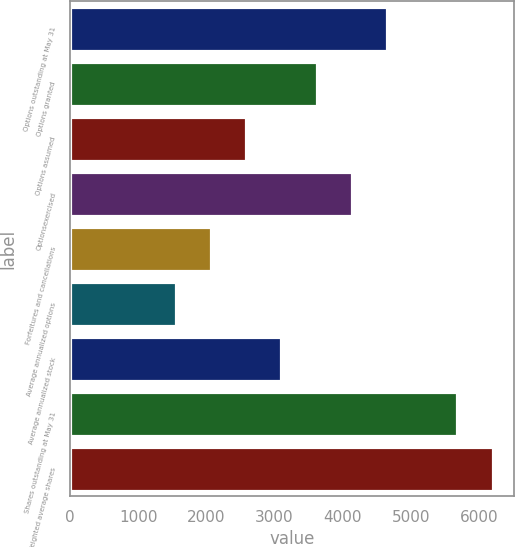Convert chart to OTSL. <chart><loc_0><loc_0><loc_500><loc_500><bar_chart><fcel>Options outstanding at May 31<fcel>Options granted<fcel>Options assumed<fcel>Optionsexercised<fcel>Forfeitures and cancellations<fcel>Average annualized options<fcel>Average annualized stock<fcel>Shares outstanding at May 31<fcel>Weighted average shares<nl><fcel>4649.55<fcel>3616.65<fcel>2583.75<fcel>4133.1<fcel>2067.3<fcel>1550.85<fcel>3100.2<fcel>5682.45<fcel>6198.9<nl></chart> 